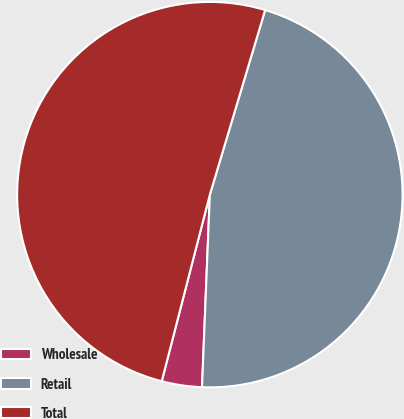Convert chart to OTSL. <chart><loc_0><loc_0><loc_500><loc_500><pie_chart><fcel>Wholesale<fcel>Retail<fcel>Total<nl><fcel>3.37%<fcel>46.01%<fcel>50.61%<nl></chart> 